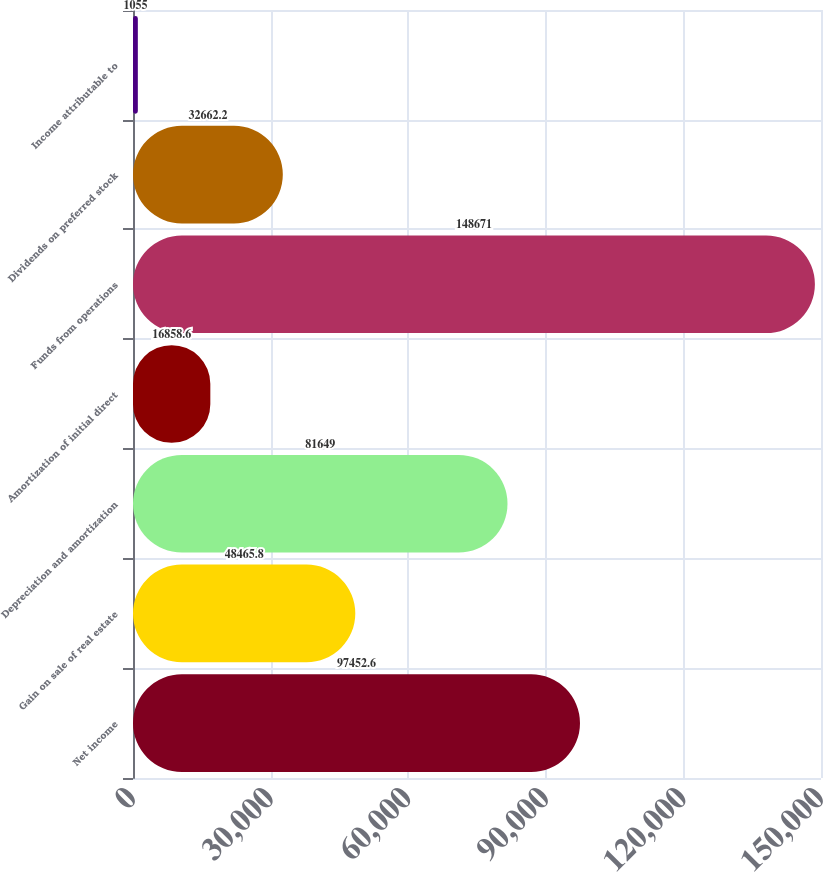Convert chart. <chart><loc_0><loc_0><loc_500><loc_500><bar_chart><fcel>Net income<fcel>Gain on sale of real estate<fcel>Depreciation and amortization<fcel>Amortization of initial direct<fcel>Funds from operations<fcel>Dividends on preferred stock<fcel>Income attributable to<nl><fcel>97452.6<fcel>48465.8<fcel>81649<fcel>16858.6<fcel>148671<fcel>32662.2<fcel>1055<nl></chart> 